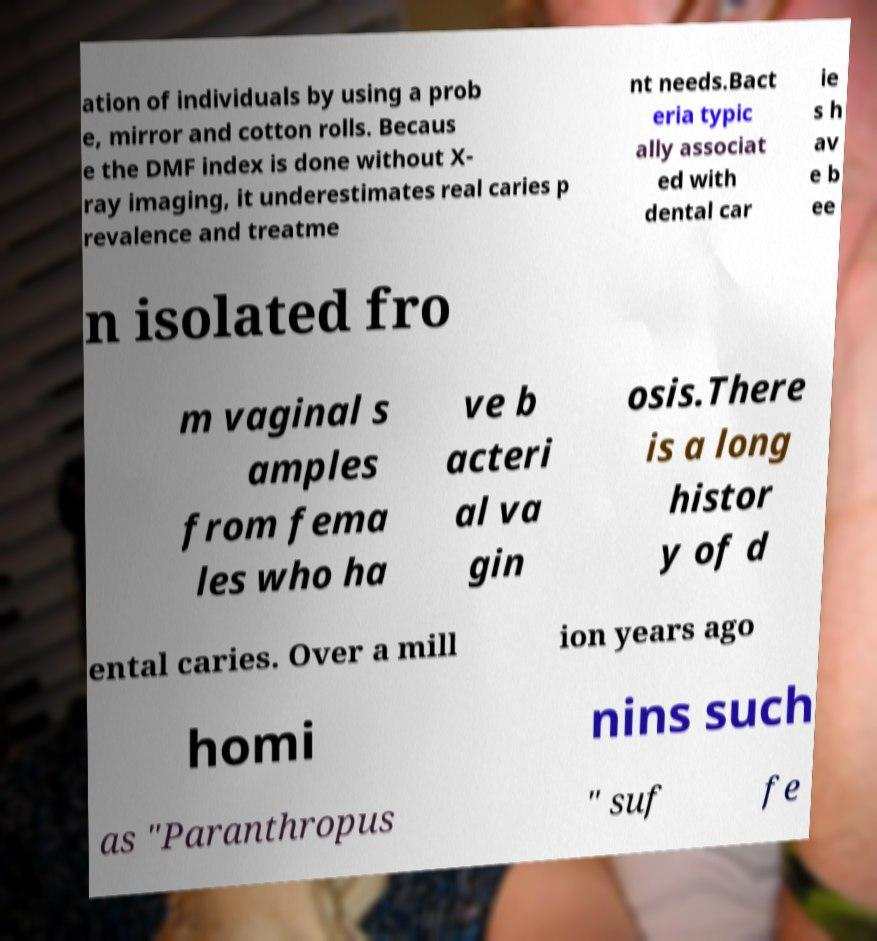Could you assist in decoding the text presented in this image and type it out clearly? ation of individuals by using a prob e, mirror and cotton rolls. Becaus e the DMF index is done without X- ray imaging, it underestimates real caries p revalence and treatme nt needs.Bact eria typic ally associat ed with dental car ie s h av e b ee n isolated fro m vaginal s amples from fema les who ha ve b acteri al va gin osis.There is a long histor y of d ental caries. Over a mill ion years ago homi nins such as "Paranthropus " suf fe 